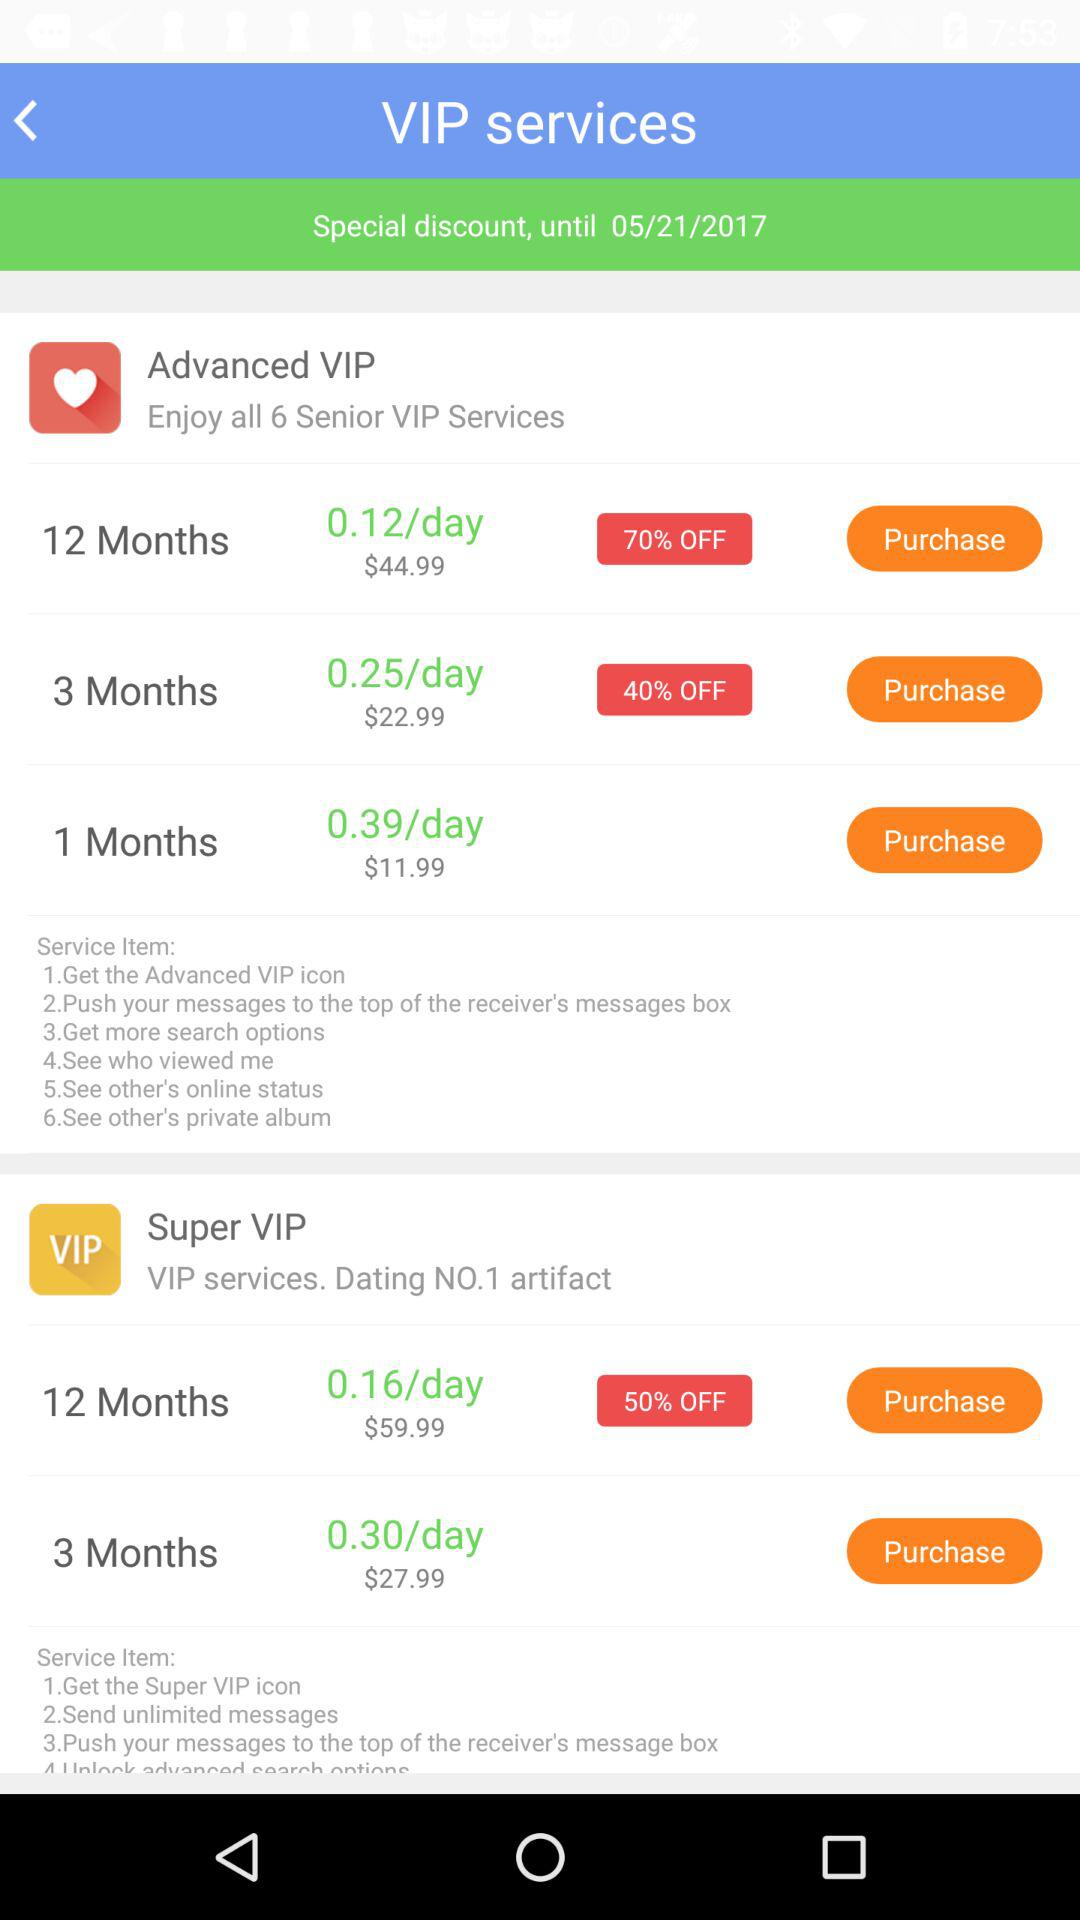What is the currency of the prices? The currency is the dollar. 